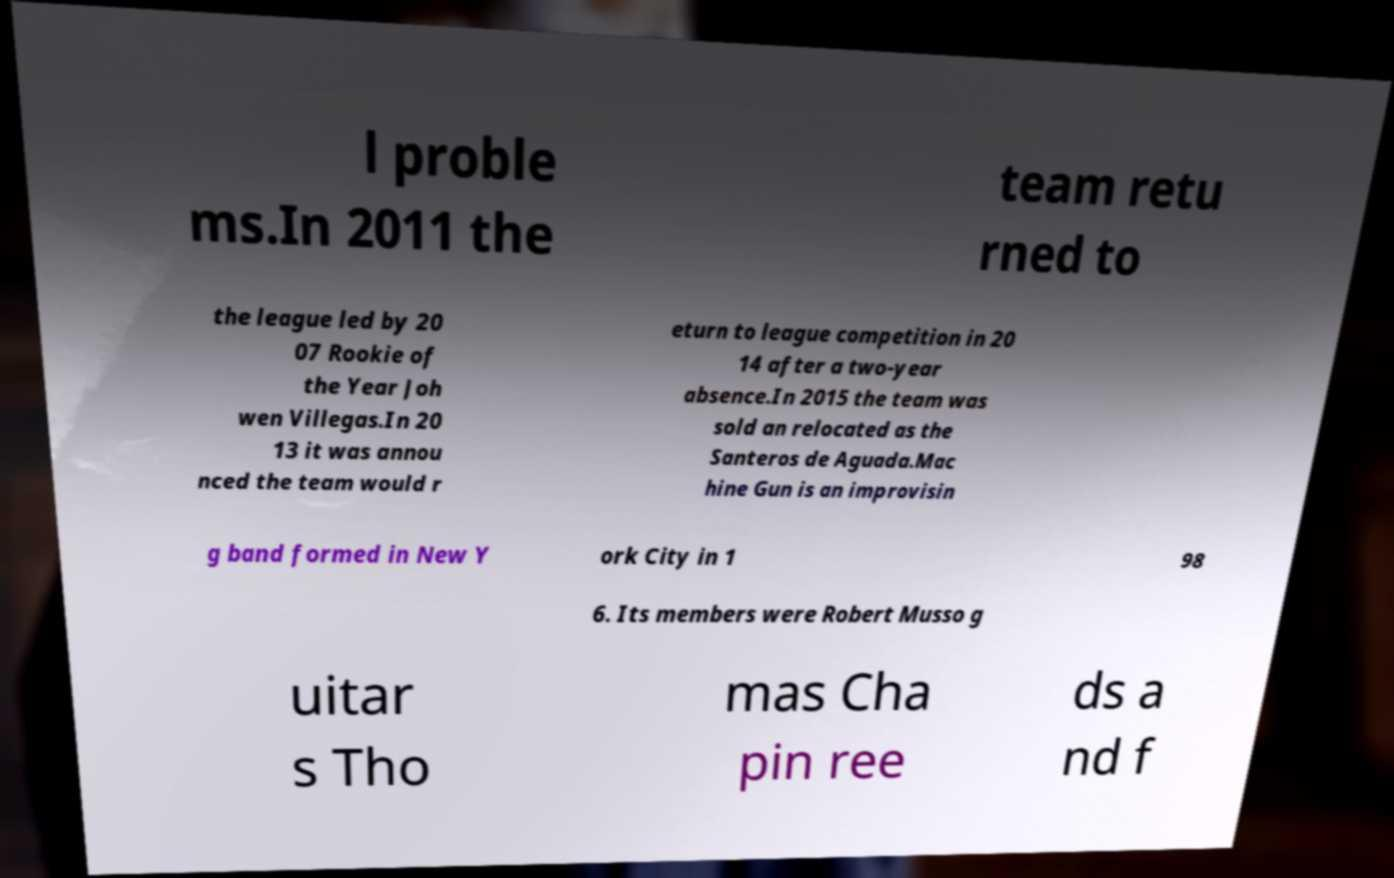Can you read and provide the text displayed in the image?This photo seems to have some interesting text. Can you extract and type it out for me? l proble ms.In 2011 the team retu rned to the league led by 20 07 Rookie of the Year Joh wen Villegas.In 20 13 it was annou nced the team would r eturn to league competition in 20 14 after a two-year absence.In 2015 the team was sold an relocated as the Santeros de Aguada.Mac hine Gun is an improvisin g band formed in New Y ork City in 1 98 6. Its members were Robert Musso g uitar s Tho mas Cha pin ree ds a nd f 